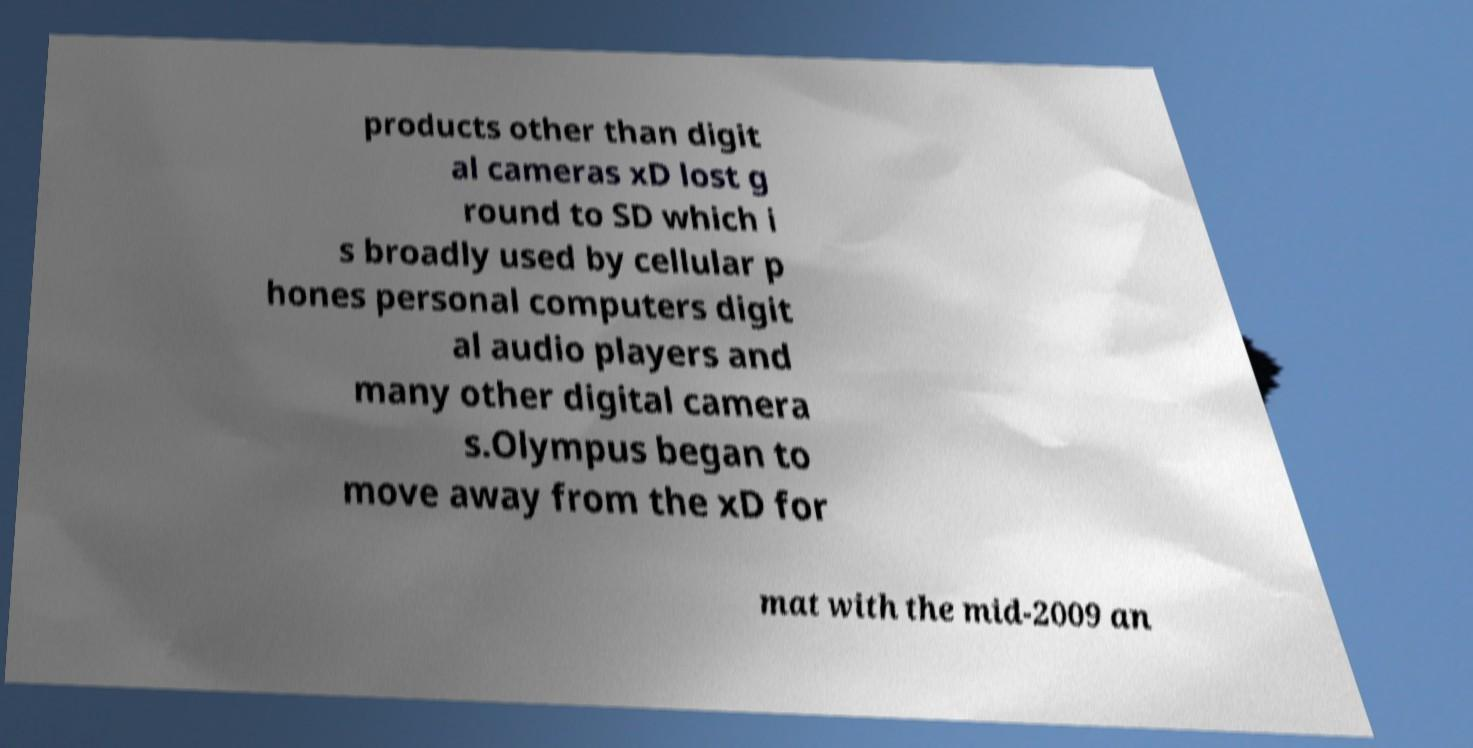Please identify and transcribe the text found in this image. products other than digit al cameras xD lost g round to SD which i s broadly used by cellular p hones personal computers digit al audio players and many other digital camera s.Olympus began to move away from the xD for mat with the mid-2009 an 